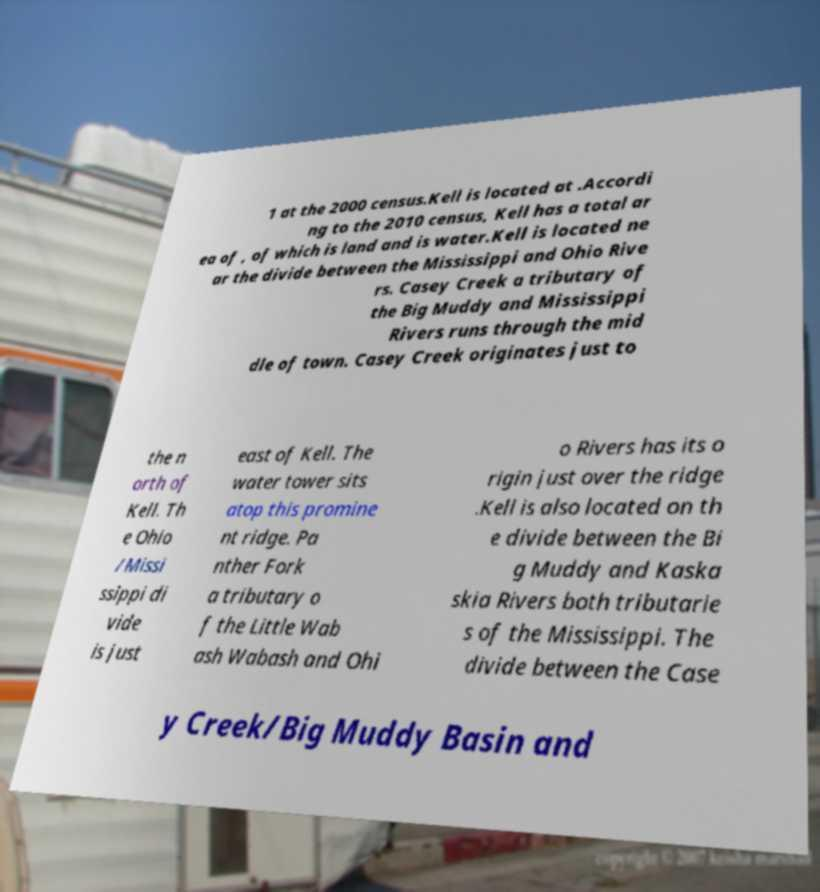Can you read and provide the text displayed in the image?This photo seems to have some interesting text. Can you extract and type it out for me? 1 at the 2000 census.Kell is located at .Accordi ng to the 2010 census, Kell has a total ar ea of , of which is land and is water.Kell is located ne ar the divide between the Mississippi and Ohio Rive rs. Casey Creek a tributary of the Big Muddy and Mississippi Rivers runs through the mid dle of town. Casey Creek originates just to the n orth of Kell. Th e Ohio /Missi ssippi di vide is just east of Kell. The water tower sits atop this promine nt ridge. Pa nther Fork a tributary o f the Little Wab ash Wabash and Ohi o Rivers has its o rigin just over the ridge .Kell is also located on th e divide between the Bi g Muddy and Kaska skia Rivers both tributarie s of the Mississippi. The divide between the Case y Creek/Big Muddy Basin and 